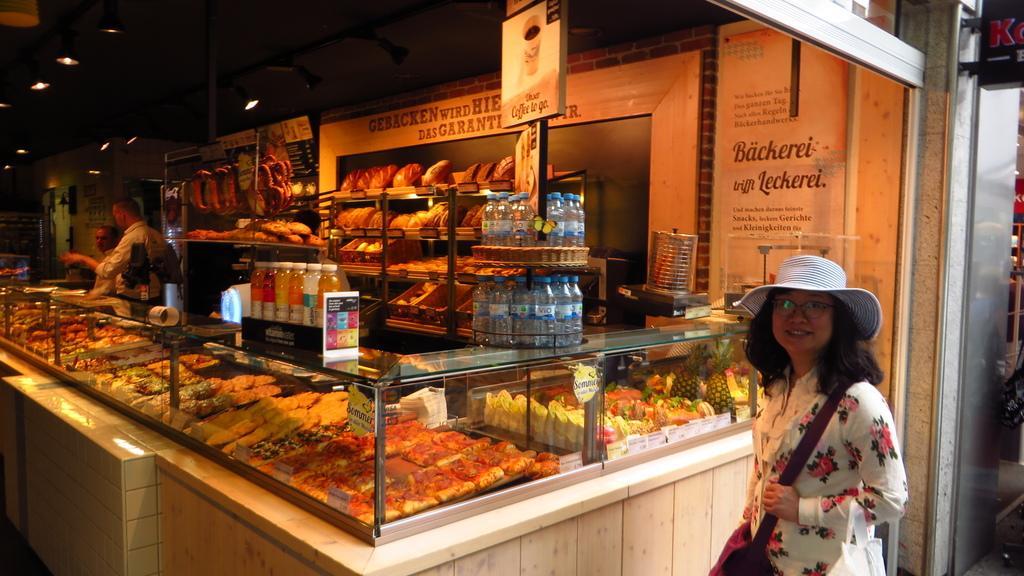Can you describe this image briefly? In this image we can see a store. In the store there are persons standing on the floor, disposal bottles, fruits, beverage bottles and different types of foods placed in the cupboards. 